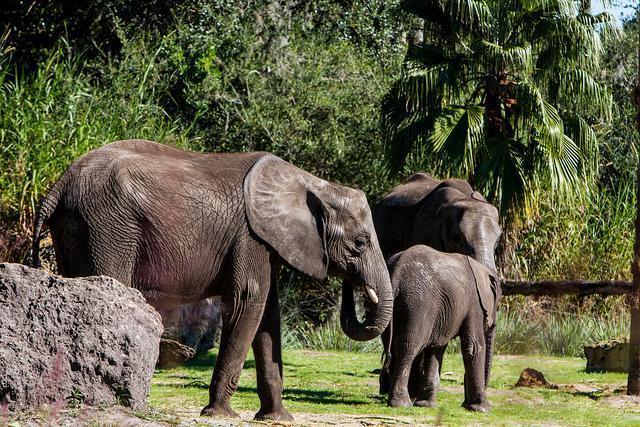How many baby elephants are in the picture?
Give a very brief answer. 1. How many elephants are there?
Give a very brief answer. 3. How many people are surfing?
Give a very brief answer. 0. 